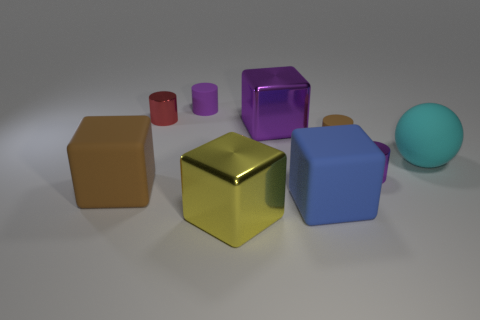Subtract all purple rubber cylinders. How many cylinders are left? 3 Subtract all purple cylinders. How many cylinders are left? 2 Subtract 3 cylinders. How many cylinders are left? 1 Subtract all cylinders. How many objects are left? 5 Subtract all big brown things. Subtract all big yellow objects. How many objects are left? 7 Add 1 small brown cylinders. How many small brown cylinders are left? 2 Add 4 metal things. How many metal things exist? 8 Subtract 1 brown cylinders. How many objects are left? 8 Subtract all yellow cubes. Subtract all green cylinders. How many cubes are left? 3 Subtract all brown balls. How many blue cubes are left? 1 